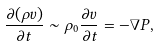Convert formula to latex. <formula><loc_0><loc_0><loc_500><loc_500>\frac { \partial ( \rho { v } ) } { \partial t } \sim \rho _ { 0 } \frac { \partial { v } } { \partial t } = - \nabla P ,</formula> 